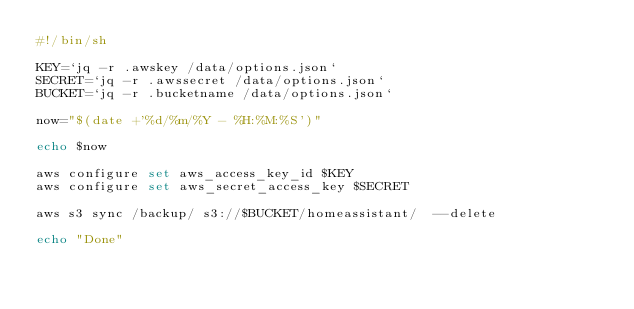Convert code to text. <code><loc_0><loc_0><loc_500><loc_500><_Bash_>#!/bin/sh

KEY=`jq -r .awskey /data/options.json`
SECRET=`jq -r .awssecret /data/options.json`
BUCKET=`jq -r .bucketname /data/options.json`

now="$(date +'%d/%m/%Y - %H:%M:%S')"

echo $now

aws configure set aws_access_key_id $KEY
aws configure set aws_secret_access_key $SECRET

aws s3 sync /backup/ s3://$BUCKET/homeassistant/  --delete

echo "Done"
</code> 